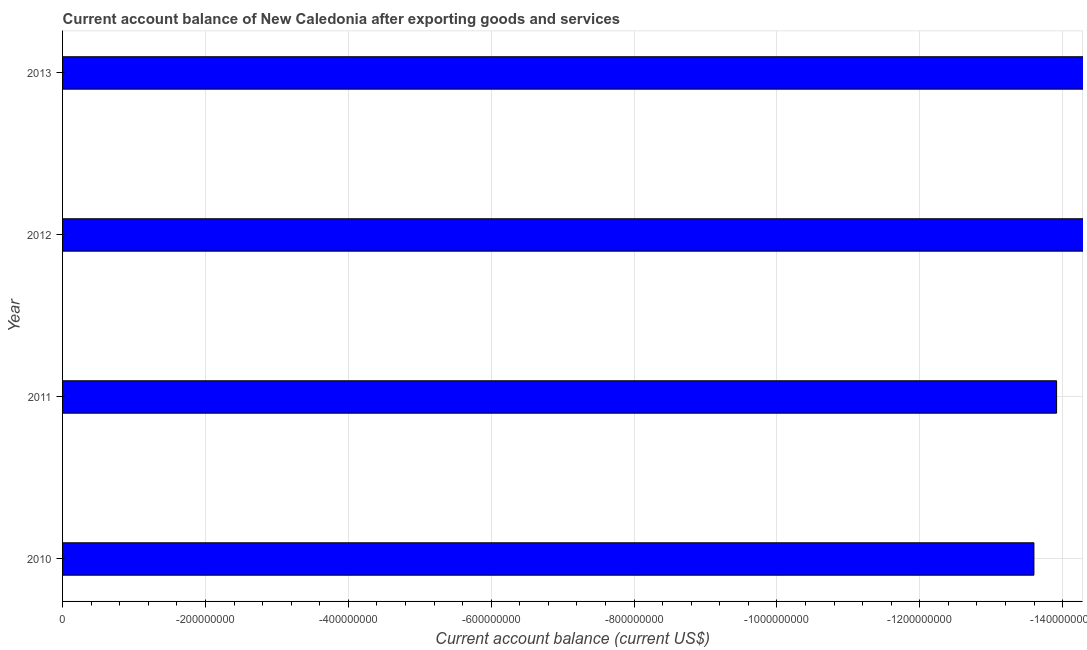Does the graph contain any zero values?
Your response must be concise. Yes. What is the title of the graph?
Provide a succinct answer. Current account balance of New Caledonia after exporting goods and services. What is the label or title of the X-axis?
Provide a short and direct response. Current account balance (current US$). What is the label or title of the Y-axis?
Offer a terse response. Year. What is the current account balance in 2011?
Provide a short and direct response. 0. Across all years, what is the minimum current account balance?
Offer a very short reply. 0. What is the median current account balance?
Keep it short and to the point. 0. How many bars are there?
Your answer should be very brief. 0. Are all the bars in the graph horizontal?
Ensure brevity in your answer.  Yes. How many years are there in the graph?
Provide a short and direct response. 4. What is the Current account balance (current US$) of 2010?
Ensure brevity in your answer.  0. What is the Current account balance (current US$) in 2012?
Offer a terse response. 0. 